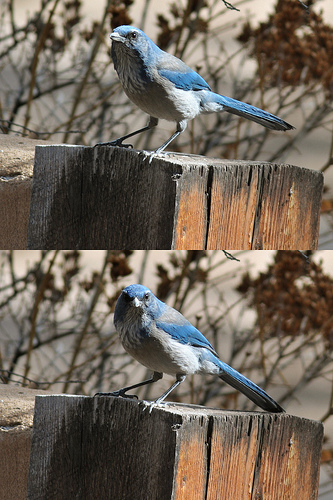<image>
Can you confirm if the trees is behind the bird? Yes. From this viewpoint, the trees is positioned behind the bird, with the bird partially or fully occluding the trees. 